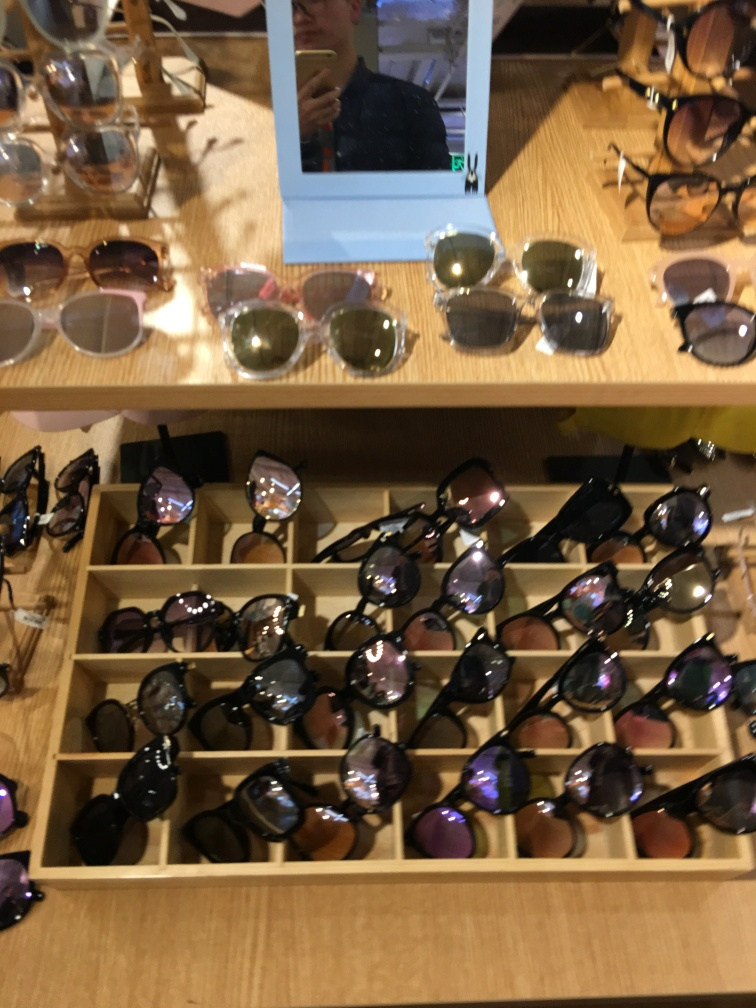Can you tell me more about the varieties of sunglasses presented here? Certainly! The image displays a diverse array of sunglasses with different frame styles, including aviators, wayfarers, and round frames. There are also various lens tints visible, ranging from light to dark shades, indicative of the variety available for different lighting conditions and personal preferences. Which pair would be best for a beach vacation? For a beach vacation, a pair with polarized lenses would be ideal to reduce glare from the water and sand. A comfortable, secure fit and UV protection are also important features to look for. 